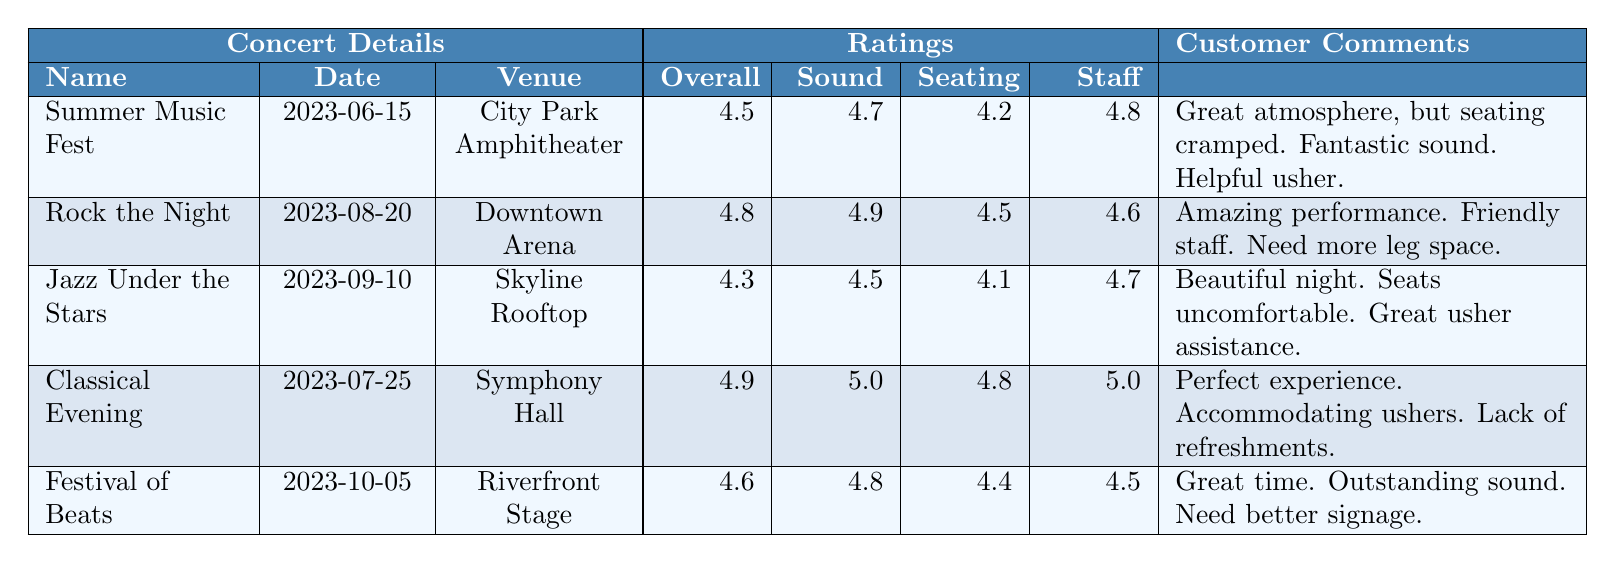What was the overall experience rating for the "Classical Evening" concert? The table indicates that the overall experience rating for the "Classical Evening" concert is found in the respective row under the "Overall" column, which shows a rating of 4.9.
Answer: 4.9 Which concert had the highest sound quality rating? By examining the "Sound" column of the table, the highest rating is 5.0, which corresponds to the "Classical Evening" concert.
Answer: Classical Evening What is the average seating comfort rating across all concerts? The seating comfort ratings are 4.2, 4.5, 4.1, 4.8, and 4.4. Adding these gives 4.2 + 4.5 + 4.1 + 4.8 + 4.4 = 22. The average is 22/5 = 4.4.
Answer: 4.4 Did the "Jazz Under the Stars" concert receive a better overall experience rating than "Summer Music Fest"? The overall experience rating for "Jazz Under the Stars" is 4.3 and for "Summer Music Fest" is 4.5. Since 4.3 is less than 4.5, it is false that "Jazz Under the Stars" did better in overall experience.
Answer: No What is the difference in staff helpfulness ratings between "Rock the Night" and "Festival of Beats"? The staff helpfulness rating for "Rock the Night" is 4.6 and for "Festival of Beats" it is 4.5. The difference is calculated as 4.6 - 4.5 = 0.1.
Answer: 0.1 Was the average overall rating across all concerts higher than 4.5? The overall ratings are 4.5, 4.8, 4.3, 4.9, and 4.6. Calculating the average gives (4.5 + 4.8 + 4.3 + 4.9 + 4.6) = 23.1, and dividing by 5 gives 23.1/5 = 4.62, which is higher than 4.5.
Answer: Yes Which concert had the lowest seating comfort rating, and what was that rating? From the "Seating" column, the lowest rating is 4.1, which corresponds to the "Jazz Under the Stars" concert.
Answer: Jazz Under the Stars, 4.1 How many concerts had an overall experience rating of 4.7 or higher? The overall experience ratings of concerts to consider are: 4.5 (Summer Music Fest), 4.8 (Rock the Night), 4.3 (Jazz Under the Stars), 4.9 (Classical Evening), and 4.6 (Festival of Beats). The concerts with ratings 4.7 or higher are Rock the Night, Classical Evening, and Festival of Beats, totaling 3 concerts.
Answer: 3 Is there any concert where all ratings (Overall, Sound, Seating, Staff) are above 4.5? Examining the ratings, only "Classical Evening" has all its ratings (4.9, 5.0, 4.8, and 5.0) above 4.5. Therefore, yes, there is such a concert.
Answer: Yes Which venue had the best-rated staff helpfulness? The ratings for staff helpfulness are: City Park Amphitheater (4.8), Downtown Arena (4.6), Skyline Rooftop (4.7), Symphony Hall (5.0), and Riverfront Stage (4.5). The highest rating, 5.0, belongs to Symphony Hall.
Answer: Symphony Hall 